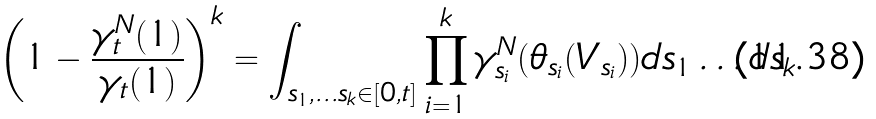Convert formula to latex. <formula><loc_0><loc_0><loc_500><loc_500>\left ( 1 - \frac { \gamma ^ { N } _ { t } ( 1 ) } { \gamma _ { t } ( 1 ) } \right ) ^ { k } = \int _ { s _ { 1 } , \dots s _ { k } \in [ 0 , t ] } \prod _ { i = 1 } ^ { k } \gamma _ { s _ { i } } ^ { N } ( \theta _ { s _ { i } } ( V _ { s _ { i } } ) ) d s _ { 1 } \dots d s _ { k }</formula> 